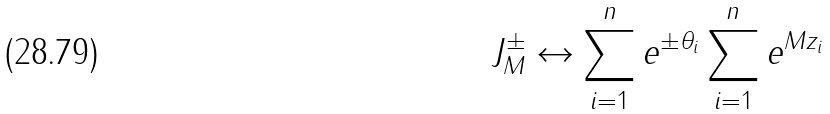Convert formula to latex. <formula><loc_0><loc_0><loc_500><loc_500>J _ { M } ^ { \pm } \leftrightarrow \sum _ { i = 1 } ^ { n } e ^ { \pm \theta _ { i } } \sum _ { i = 1 } ^ { n } e ^ { M z _ { i } }</formula> 